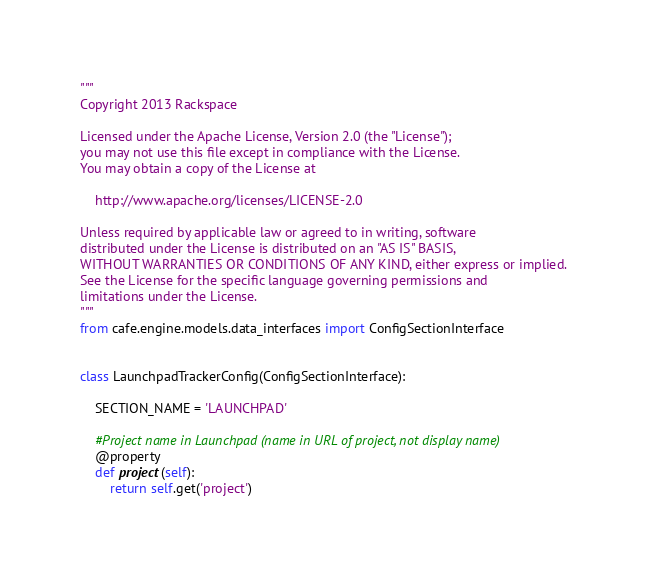<code> <loc_0><loc_0><loc_500><loc_500><_Python_>"""
Copyright 2013 Rackspace

Licensed under the Apache License, Version 2.0 (the "License");
you may not use this file except in compliance with the License.
You may obtain a copy of the License at

    http://www.apache.org/licenses/LICENSE-2.0

Unless required by applicable law or agreed to in writing, software
distributed under the License is distributed on an "AS IS" BASIS,
WITHOUT WARRANTIES OR CONDITIONS OF ANY KIND, either express or implied.
See the License for the specific language governing permissions and
limitations under the License.
"""
from cafe.engine.models.data_interfaces import ConfigSectionInterface


class LaunchpadTrackerConfig(ConfigSectionInterface):

    SECTION_NAME = 'LAUNCHPAD'

    #Project name in Launchpad (name in URL of project, not display name)
    @property
    def project(self):
        return self.get('project')
</code> 